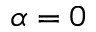<formula> <loc_0><loc_0><loc_500><loc_500>\alpha = 0</formula> 